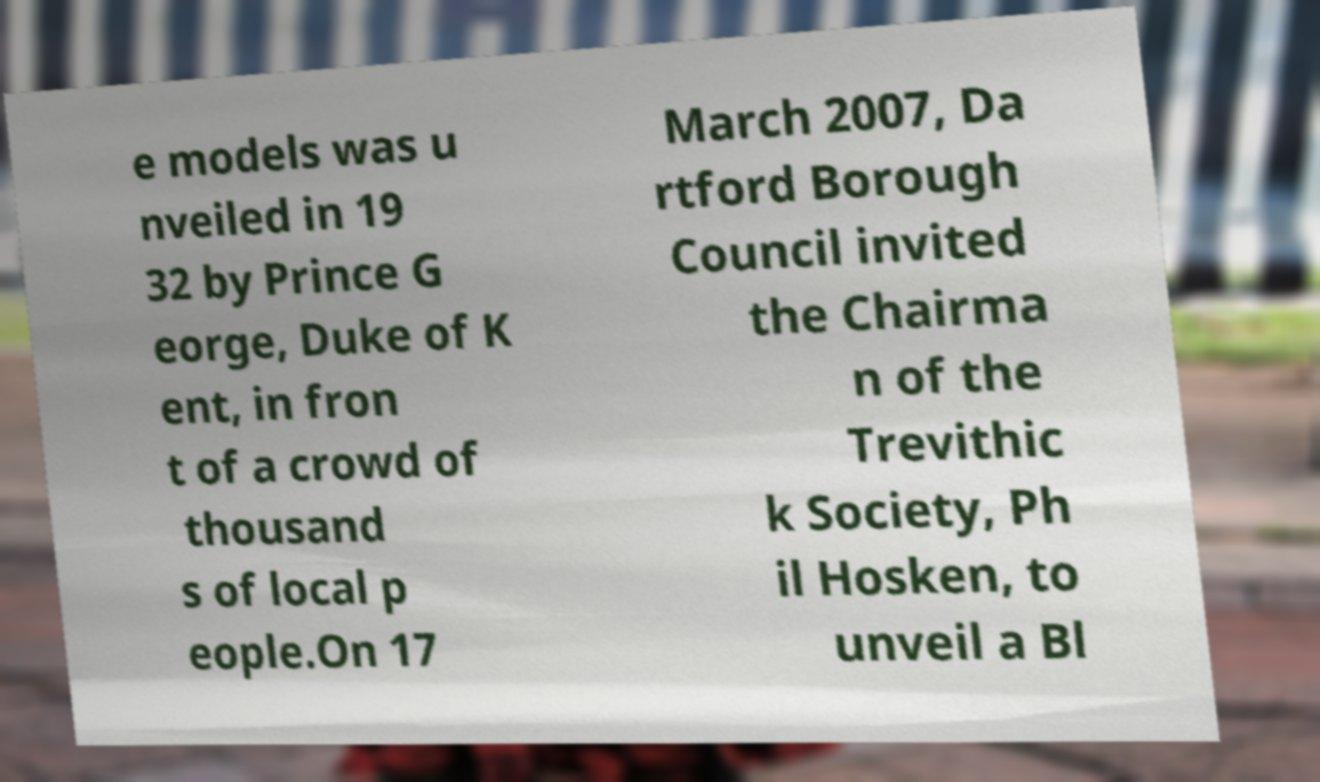Can you read and provide the text displayed in the image?This photo seems to have some interesting text. Can you extract and type it out for me? e models was u nveiled in 19 32 by Prince G eorge, Duke of K ent, in fron t of a crowd of thousand s of local p eople.On 17 March 2007, Da rtford Borough Council invited the Chairma n of the Trevithic k Society, Ph il Hosken, to unveil a Bl 